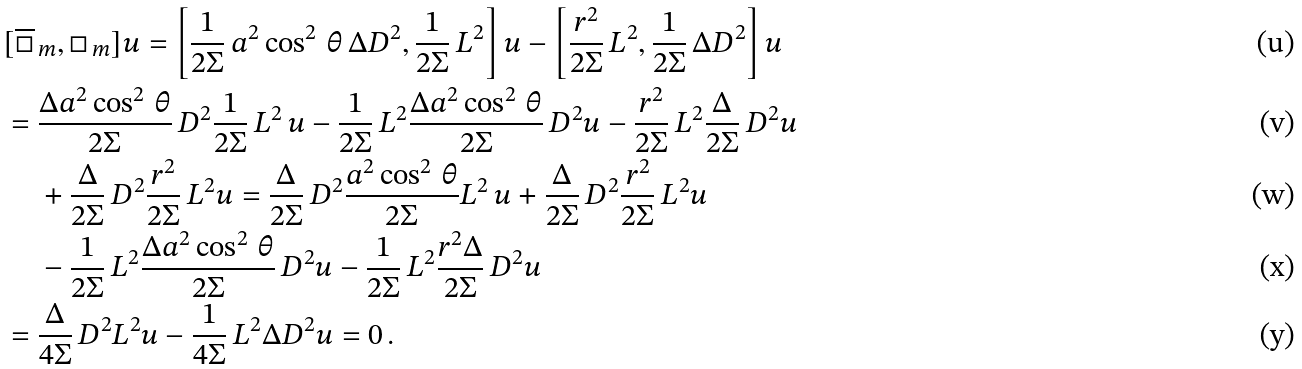Convert formula to latex. <formula><loc_0><loc_0><loc_500><loc_500>& [ \overline { \Box } _ { \, m } , \Box _ { \, m } ] u = \left [ \frac { 1 } { 2 \Sigma } \, a ^ { 2 } \cos ^ { 2 } \, \theta \, \Delta D ^ { 2 } , \frac { 1 } { 2 \Sigma } \, L ^ { 2 } \right ] u - \left [ \frac { r ^ { 2 } } { 2 \Sigma } \, L ^ { 2 } , \frac { 1 } { 2 \Sigma } \, \Delta D ^ { 2 } \right ] u \\ & = \frac { \Delta a ^ { 2 } \cos ^ { 2 } \, \theta } { 2 \Sigma } \, D ^ { 2 } \frac { 1 } { 2 \Sigma } \, L ^ { 2 } \, u - \frac { 1 } { 2 \Sigma } \, L ^ { 2 } \frac { \Delta a ^ { 2 } \cos ^ { 2 } \, \theta } { 2 \Sigma } \, D ^ { 2 } u - \frac { r ^ { 2 } } { 2 \Sigma } \, L ^ { 2 } \frac { \Delta } { 2 \Sigma } \, D ^ { 2 } u \\ & \quad \, + \frac { \Delta } { 2 \Sigma } \, D ^ { 2 } \frac { r ^ { 2 } } { 2 \Sigma } \, L ^ { 2 } u = \frac { \Delta } { 2 \Sigma } \, D ^ { 2 } \frac { a ^ { 2 } \cos ^ { 2 } \, \theta } { 2 \Sigma } L ^ { 2 } \, u + \frac { \Delta } { 2 \Sigma } \, D ^ { 2 } \frac { r ^ { 2 } } { 2 \Sigma } \, L ^ { 2 } u \\ & \quad \, - \frac { 1 } { 2 \Sigma } \, L ^ { 2 } \frac { \Delta a ^ { 2 } \cos ^ { 2 } \, \theta } { 2 \Sigma } \, D ^ { 2 } u - \frac { 1 } { 2 \Sigma } \, L ^ { 2 } \frac { r ^ { 2 } \Delta } { 2 \Sigma } \, D ^ { 2 } u \\ & = \frac { \Delta } { 4 \Sigma } \, D ^ { 2 } L ^ { 2 } u - \frac { 1 } { 4 \Sigma } \, L ^ { 2 } \Delta D ^ { 2 } u = 0 \, .</formula> 